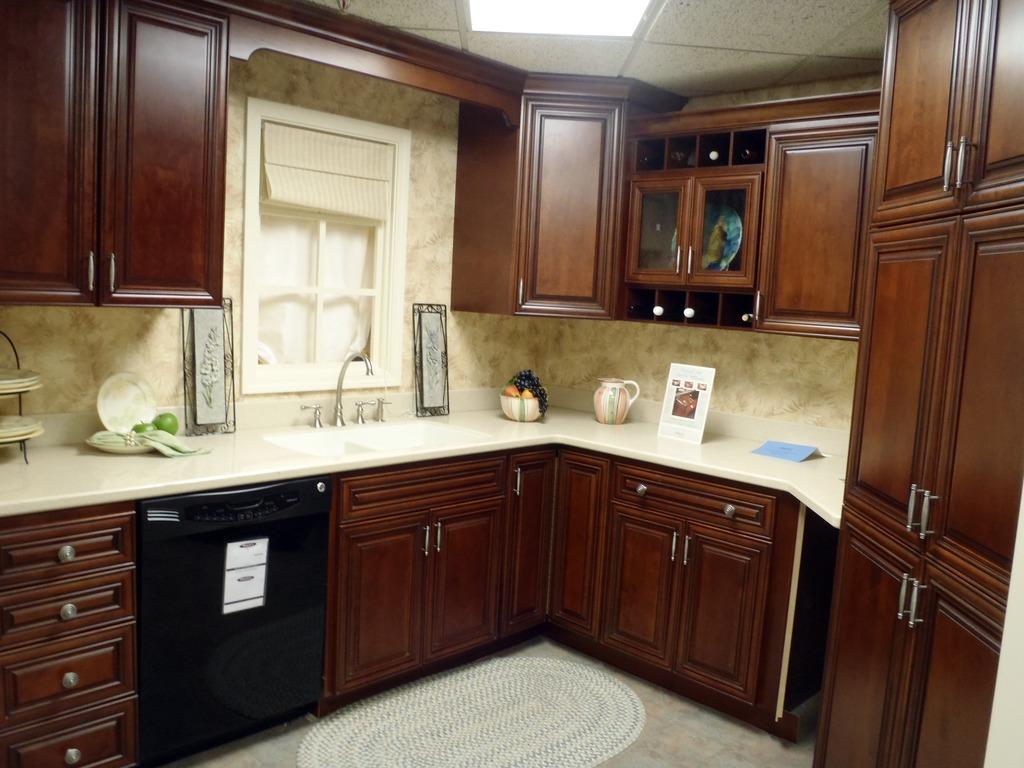How would you summarize this image in a sentence or two? This image is taken inside a room. There is a platform on which there are objects. there are cupboards. There is window. At the top of the image there is a ceiling with lights. To the right side of the image there is a cupboard. 